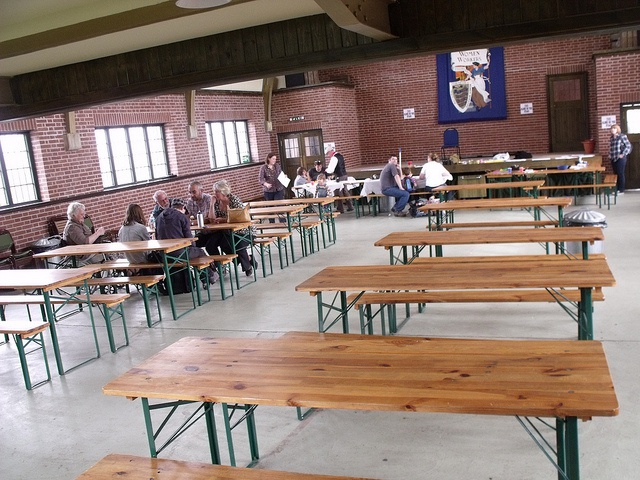Describe the objects in this image and their specific colors. I can see dining table in gray, tan, and brown tones, dining table in gray, tan, darkgray, and black tones, dining table in gray, lavender, and darkgray tones, people in gray, black, and darkgray tones, and dining table in gray, tan, and brown tones in this image. 